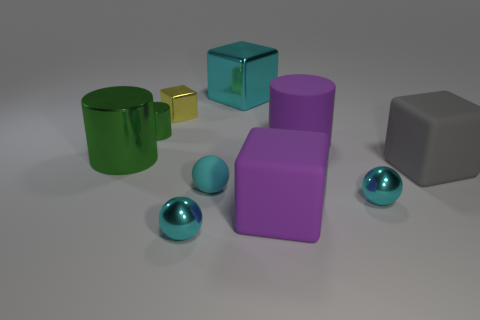Do the big metal block and the matte sphere have the same color?
Offer a terse response. Yes. Is there a large shiny thing that has the same shape as the small yellow shiny thing?
Ensure brevity in your answer.  Yes. How many objects are cyan metallic balls right of the cyan matte ball or metal spheres?
Your response must be concise. 2. Is the number of green metal cylinders that are behind the cyan metallic block greater than the number of rubber blocks that are behind the small matte object?
Give a very brief answer. No. What number of shiny objects are either tiny blue blocks or purple cylinders?
Offer a terse response. 0. There is a big thing that is the same color as the rubber sphere; what is its material?
Make the answer very short. Metal. Is the number of large cyan metallic objects that are on the right side of the big purple matte cube less than the number of large metal objects that are right of the tiny yellow metal cube?
Make the answer very short. Yes. How many objects are purple metal things or metallic cubes that are to the left of the large metal block?
Provide a succinct answer. 1. What material is the purple block that is the same size as the cyan metallic block?
Give a very brief answer. Rubber. Is the material of the large purple cylinder the same as the gray block?
Ensure brevity in your answer.  Yes. 